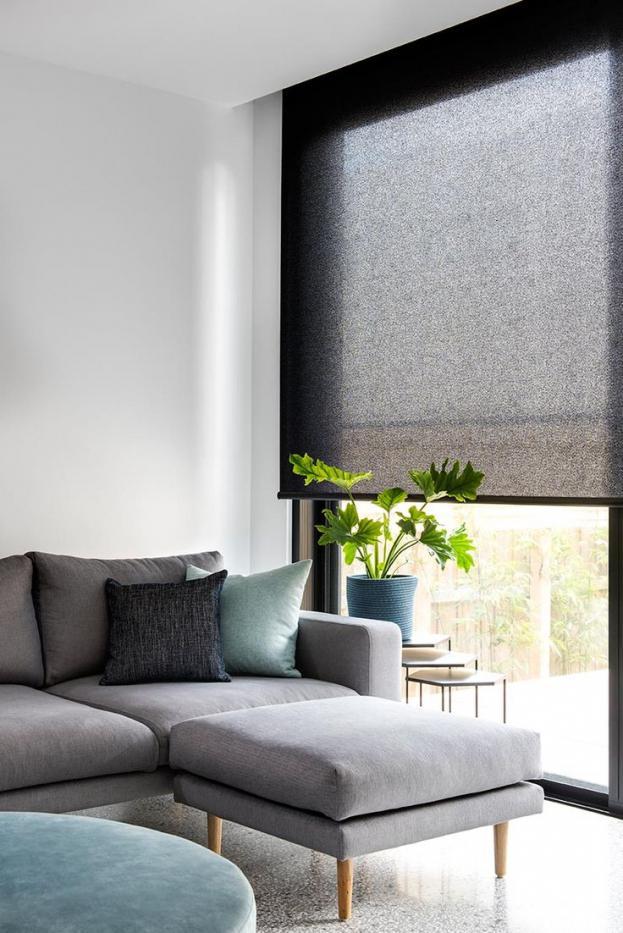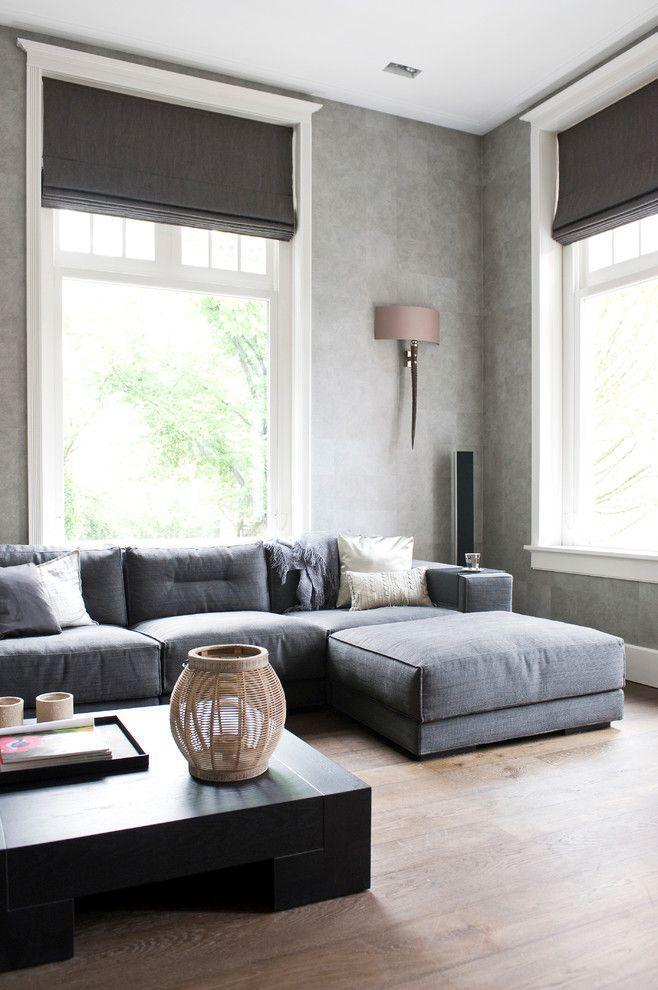The first image is the image on the left, the second image is the image on the right. Considering the images on both sides, is "There are three window shades in one image, and four window shades in the other image." valid? Answer yes or no. No. The first image is the image on the left, the second image is the image on the right. For the images displayed, is the sentence "In the image to the left, you can see the lamp." factually correct? Answer yes or no. No. 